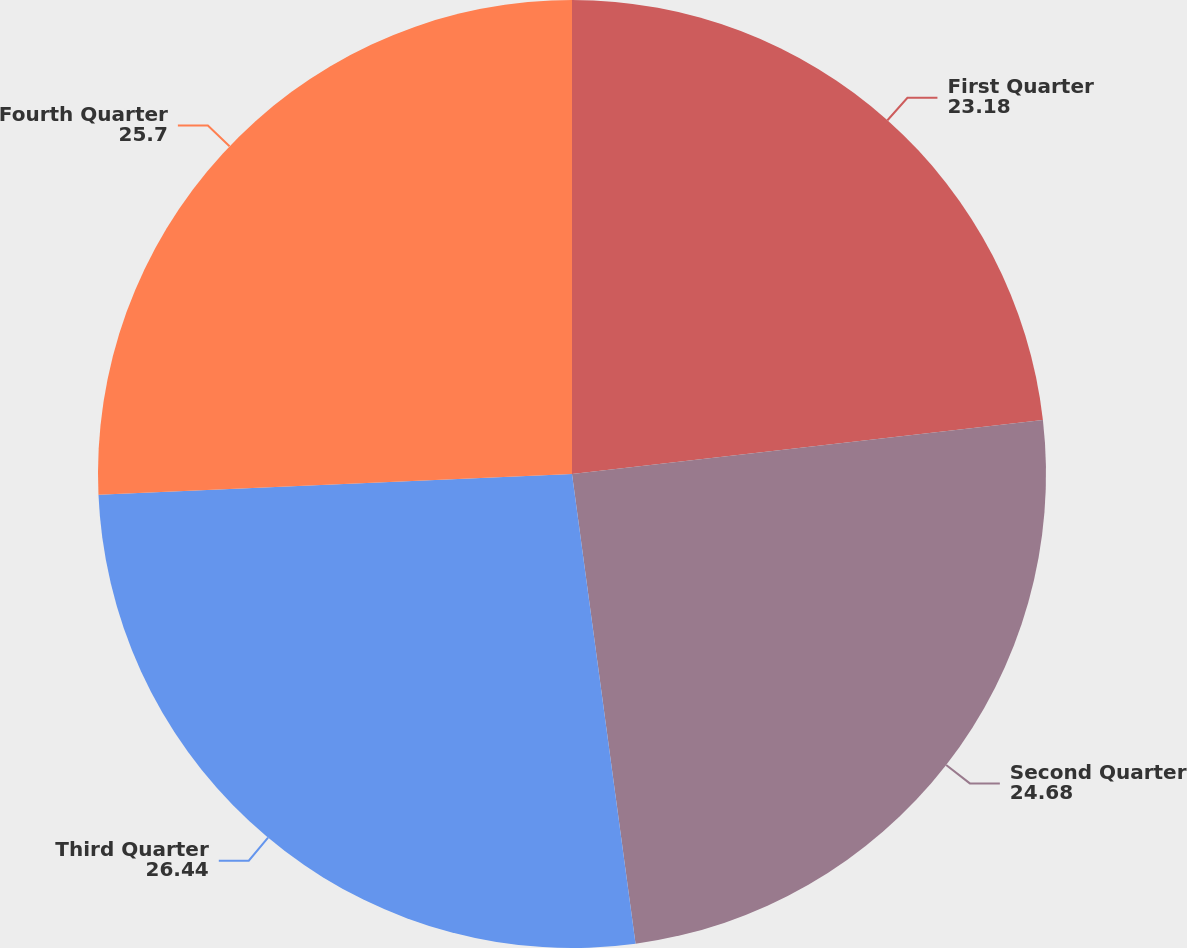Convert chart to OTSL. <chart><loc_0><loc_0><loc_500><loc_500><pie_chart><fcel>First Quarter<fcel>Second Quarter<fcel>Third Quarter<fcel>Fourth Quarter<nl><fcel>23.18%<fcel>24.68%<fcel>26.44%<fcel>25.7%<nl></chart> 